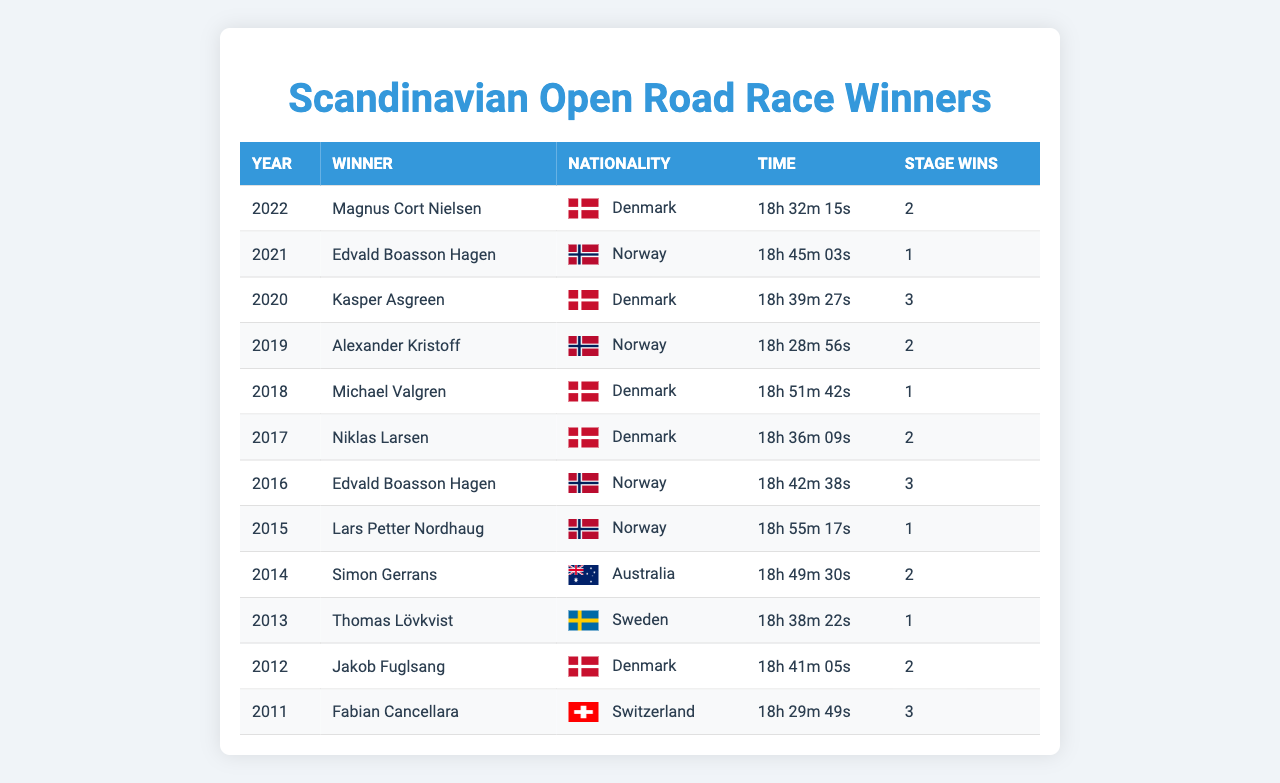What was the winning time in 2022? The table shows that the winning time in 2022 was "18h 32m 15s".
Answer: 18h 32m 15s Which nationality won the race most recently? Observing the table, the winner in the most recent year, 2022, was from Denmark.
Answer: Denmark How many stage wins did the winner from Norway achieve in 2021? Referring to the table, the winner in 2021, Edvald Boasson Hagen, had 1 stage win.
Answer: 1 Which year had the fastest winning time and what was the time? The fastest winning time is in 2019 for Alexander Kristoff, which was "18h 28m 56s".
Answer: 2019, 18h 28m 56s Out of all the winners, which country has the most representatives? By counting the occurrences in the Nationality column, Denmark has 5 winners, more than any other country.
Answer: Denmark What is the total number of stage wins by the winner from Denmark? Adding all stage wins by Danish winners (2+3+1+2+2), the total is 10 stage wins.
Answer: 10 Did any winner achieve more than 3 stage wins in a single year? Checking the Stage Wins column, no winner has more than 3 stage wins in a single year.
Answer: No What is the average winning time of the winners from Norway? The winning times for Norway are 18h 45m 03s, 18h 28m 56s, and 18h 42m 38s. Converting these to seconds: (66903 + 66176 + 67238) / 3 = 66705.67 seconds, which is about 18h 32m.
Answer: 18h 32m In which years did Denmark win the race? Reviewing the table, Denmark won in 2022, 2020, 2018, 2017, and 2012, totaling five wins.
Answer: 5 years Was there any year where the winner was from Australia? The table indicates that Simon Gerrans from Australia won in 2014.
Answer: Yes, 2014 